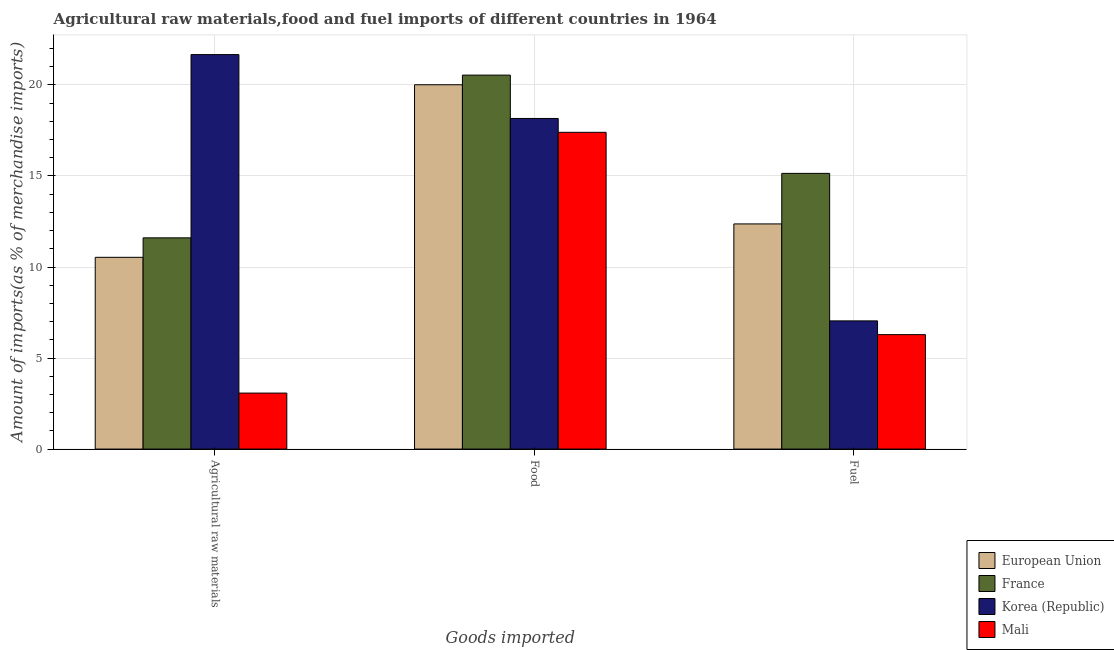How many groups of bars are there?
Offer a very short reply. 3. Are the number of bars per tick equal to the number of legend labels?
Ensure brevity in your answer.  Yes. Are the number of bars on each tick of the X-axis equal?
Your answer should be compact. Yes. How many bars are there on the 3rd tick from the right?
Give a very brief answer. 4. What is the label of the 3rd group of bars from the left?
Keep it short and to the point. Fuel. What is the percentage of raw materials imports in Korea (Republic)?
Keep it short and to the point. 21.67. Across all countries, what is the maximum percentage of food imports?
Offer a very short reply. 20.54. Across all countries, what is the minimum percentage of food imports?
Your answer should be compact. 17.4. In which country was the percentage of raw materials imports minimum?
Your answer should be very brief. Mali. What is the total percentage of food imports in the graph?
Provide a short and direct response. 76.11. What is the difference between the percentage of food imports in France and that in Mali?
Provide a succinct answer. 3.14. What is the difference between the percentage of raw materials imports in Korea (Republic) and the percentage of food imports in France?
Give a very brief answer. 1.13. What is the average percentage of food imports per country?
Make the answer very short. 19.03. What is the difference between the percentage of raw materials imports and percentage of fuel imports in France?
Make the answer very short. -3.54. In how many countries, is the percentage of food imports greater than 2 %?
Your answer should be very brief. 4. What is the ratio of the percentage of food imports in European Union to that in Mali?
Your answer should be very brief. 1.15. Is the difference between the percentage of food imports in Mali and European Union greater than the difference between the percentage of raw materials imports in Mali and European Union?
Offer a very short reply. Yes. What is the difference between the highest and the second highest percentage of food imports?
Keep it short and to the point. 0.53. What is the difference between the highest and the lowest percentage of fuel imports?
Give a very brief answer. 8.86. In how many countries, is the percentage of fuel imports greater than the average percentage of fuel imports taken over all countries?
Provide a succinct answer. 2. Is the sum of the percentage of food imports in Mali and Korea (Republic) greater than the maximum percentage of raw materials imports across all countries?
Give a very brief answer. Yes. What does the 1st bar from the right in Food represents?
Offer a terse response. Mali. Is it the case that in every country, the sum of the percentage of raw materials imports and percentage of food imports is greater than the percentage of fuel imports?
Keep it short and to the point. Yes. How many bars are there?
Offer a very short reply. 12. Are the values on the major ticks of Y-axis written in scientific E-notation?
Your answer should be very brief. No. Does the graph contain any zero values?
Offer a very short reply. No. Does the graph contain grids?
Provide a succinct answer. Yes. Where does the legend appear in the graph?
Ensure brevity in your answer.  Bottom right. How many legend labels are there?
Provide a short and direct response. 4. What is the title of the graph?
Keep it short and to the point. Agricultural raw materials,food and fuel imports of different countries in 1964. What is the label or title of the X-axis?
Your answer should be compact. Goods imported. What is the label or title of the Y-axis?
Make the answer very short. Amount of imports(as % of merchandise imports). What is the Amount of imports(as % of merchandise imports) of European Union in Agricultural raw materials?
Your answer should be very brief. 10.53. What is the Amount of imports(as % of merchandise imports) in France in Agricultural raw materials?
Make the answer very short. 11.6. What is the Amount of imports(as % of merchandise imports) in Korea (Republic) in Agricultural raw materials?
Your response must be concise. 21.67. What is the Amount of imports(as % of merchandise imports) in Mali in Agricultural raw materials?
Offer a very short reply. 3.08. What is the Amount of imports(as % of merchandise imports) of European Union in Food?
Your answer should be very brief. 20.01. What is the Amount of imports(as % of merchandise imports) in France in Food?
Give a very brief answer. 20.54. What is the Amount of imports(as % of merchandise imports) of Korea (Republic) in Food?
Keep it short and to the point. 18.16. What is the Amount of imports(as % of merchandise imports) in Mali in Food?
Provide a short and direct response. 17.4. What is the Amount of imports(as % of merchandise imports) of European Union in Fuel?
Offer a very short reply. 12.37. What is the Amount of imports(as % of merchandise imports) in France in Fuel?
Your response must be concise. 15.14. What is the Amount of imports(as % of merchandise imports) in Korea (Republic) in Fuel?
Provide a short and direct response. 7.04. What is the Amount of imports(as % of merchandise imports) in Mali in Fuel?
Keep it short and to the point. 6.29. Across all Goods imported, what is the maximum Amount of imports(as % of merchandise imports) of European Union?
Offer a very short reply. 20.01. Across all Goods imported, what is the maximum Amount of imports(as % of merchandise imports) in France?
Your answer should be very brief. 20.54. Across all Goods imported, what is the maximum Amount of imports(as % of merchandise imports) in Korea (Republic)?
Your answer should be very brief. 21.67. Across all Goods imported, what is the maximum Amount of imports(as % of merchandise imports) in Mali?
Your answer should be compact. 17.4. Across all Goods imported, what is the minimum Amount of imports(as % of merchandise imports) in European Union?
Keep it short and to the point. 10.53. Across all Goods imported, what is the minimum Amount of imports(as % of merchandise imports) of France?
Ensure brevity in your answer.  11.6. Across all Goods imported, what is the minimum Amount of imports(as % of merchandise imports) in Korea (Republic)?
Provide a short and direct response. 7.04. Across all Goods imported, what is the minimum Amount of imports(as % of merchandise imports) in Mali?
Make the answer very short. 3.08. What is the total Amount of imports(as % of merchandise imports) in European Union in the graph?
Make the answer very short. 42.91. What is the total Amount of imports(as % of merchandise imports) in France in the graph?
Ensure brevity in your answer.  47.29. What is the total Amount of imports(as % of merchandise imports) of Korea (Republic) in the graph?
Your answer should be very brief. 46.87. What is the total Amount of imports(as % of merchandise imports) in Mali in the graph?
Ensure brevity in your answer.  26.76. What is the difference between the Amount of imports(as % of merchandise imports) in European Union in Agricultural raw materials and that in Food?
Ensure brevity in your answer.  -9.48. What is the difference between the Amount of imports(as % of merchandise imports) of France in Agricultural raw materials and that in Food?
Your response must be concise. -8.94. What is the difference between the Amount of imports(as % of merchandise imports) in Korea (Republic) in Agricultural raw materials and that in Food?
Offer a terse response. 3.51. What is the difference between the Amount of imports(as % of merchandise imports) of Mali in Agricultural raw materials and that in Food?
Keep it short and to the point. -14.32. What is the difference between the Amount of imports(as % of merchandise imports) of European Union in Agricultural raw materials and that in Fuel?
Your answer should be compact. -1.84. What is the difference between the Amount of imports(as % of merchandise imports) of France in Agricultural raw materials and that in Fuel?
Make the answer very short. -3.54. What is the difference between the Amount of imports(as % of merchandise imports) of Korea (Republic) in Agricultural raw materials and that in Fuel?
Your response must be concise. 14.63. What is the difference between the Amount of imports(as % of merchandise imports) in Mali in Agricultural raw materials and that in Fuel?
Provide a succinct answer. -3.21. What is the difference between the Amount of imports(as % of merchandise imports) of European Union in Food and that in Fuel?
Offer a very short reply. 7.64. What is the difference between the Amount of imports(as % of merchandise imports) in France in Food and that in Fuel?
Keep it short and to the point. 5.4. What is the difference between the Amount of imports(as % of merchandise imports) of Korea (Republic) in Food and that in Fuel?
Make the answer very short. 11.12. What is the difference between the Amount of imports(as % of merchandise imports) of Mali in Food and that in Fuel?
Your answer should be compact. 11.11. What is the difference between the Amount of imports(as % of merchandise imports) of European Union in Agricultural raw materials and the Amount of imports(as % of merchandise imports) of France in Food?
Give a very brief answer. -10.01. What is the difference between the Amount of imports(as % of merchandise imports) in European Union in Agricultural raw materials and the Amount of imports(as % of merchandise imports) in Korea (Republic) in Food?
Offer a very short reply. -7.63. What is the difference between the Amount of imports(as % of merchandise imports) of European Union in Agricultural raw materials and the Amount of imports(as % of merchandise imports) of Mali in Food?
Provide a succinct answer. -6.87. What is the difference between the Amount of imports(as % of merchandise imports) of France in Agricultural raw materials and the Amount of imports(as % of merchandise imports) of Korea (Republic) in Food?
Your response must be concise. -6.56. What is the difference between the Amount of imports(as % of merchandise imports) in France in Agricultural raw materials and the Amount of imports(as % of merchandise imports) in Mali in Food?
Keep it short and to the point. -5.8. What is the difference between the Amount of imports(as % of merchandise imports) of Korea (Republic) in Agricultural raw materials and the Amount of imports(as % of merchandise imports) of Mali in Food?
Your response must be concise. 4.27. What is the difference between the Amount of imports(as % of merchandise imports) in European Union in Agricultural raw materials and the Amount of imports(as % of merchandise imports) in France in Fuel?
Provide a short and direct response. -4.61. What is the difference between the Amount of imports(as % of merchandise imports) of European Union in Agricultural raw materials and the Amount of imports(as % of merchandise imports) of Korea (Republic) in Fuel?
Your answer should be compact. 3.49. What is the difference between the Amount of imports(as % of merchandise imports) in European Union in Agricultural raw materials and the Amount of imports(as % of merchandise imports) in Mali in Fuel?
Provide a succinct answer. 4.25. What is the difference between the Amount of imports(as % of merchandise imports) of France in Agricultural raw materials and the Amount of imports(as % of merchandise imports) of Korea (Republic) in Fuel?
Your answer should be compact. 4.56. What is the difference between the Amount of imports(as % of merchandise imports) of France in Agricultural raw materials and the Amount of imports(as % of merchandise imports) of Mali in Fuel?
Ensure brevity in your answer.  5.32. What is the difference between the Amount of imports(as % of merchandise imports) in Korea (Republic) in Agricultural raw materials and the Amount of imports(as % of merchandise imports) in Mali in Fuel?
Your response must be concise. 15.38. What is the difference between the Amount of imports(as % of merchandise imports) in European Union in Food and the Amount of imports(as % of merchandise imports) in France in Fuel?
Your response must be concise. 4.87. What is the difference between the Amount of imports(as % of merchandise imports) in European Union in Food and the Amount of imports(as % of merchandise imports) in Korea (Republic) in Fuel?
Keep it short and to the point. 12.97. What is the difference between the Amount of imports(as % of merchandise imports) of European Union in Food and the Amount of imports(as % of merchandise imports) of Mali in Fuel?
Ensure brevity in your answer.  13.73. What is the difference between the Amount of imports(as % of merchandise imports) of France in Food and the Amount of imports(as % of merchandise imports) of Korea (Republic) in Fuel?
Offer a terse response. 13.5. What is the difference between the Amount of imports(as % of merchandise imports) in France in Food and the Amount of imports(as % of merchandise imports) in Mali in Fuel?
Your response must be concise. 14.26. What is the difference between the Amount of imports(as % of merchandise imports) in Korea (Republic) in Food and the Amount of imports(as % of merchandise imports) in Mali in Fuel?
Offer a very short reply. 11.87. What is the average Amount of imports(as % of merchandise imports) in European Union per Goods imported?
Your answer should be very brief. 14.3. What is the average Amount of imports(as % of merchandise imports) in France per Goods imported?
Provide a short and direct response. 15.76. What is the average Amount of imports(as % of merchandise imports) of Korea (Republic) per Goods imported?
Give a very brief answer. 15.62. What is the average Amount of imports(as % of merchandise imports) of Mali per Goods imported?
Keep it short and to the point. 8.92. What is the difference between the Amount of imports(as % of merchandise imports) of European Union and Amount of imports(as % of merchandise imports) of France in Agricultural raw materials?
Provide a succinct answer. -1.07. What is the difference between the Amount of imports(as % of merchandise imports) of European Union and Amount of imports(as % of merchandise imports) of Korea (Republic) in Agricultural raw materials?
Give a very brief answer. -11.14. What is the difference between the Amount of imports(as % of merchandise imports) of European Union and Amount of imports(as % of merchandise imports) of Mali in Agricultural raw materials?
Your answer should be very brief. 7.46. What is the difference between the Amount of imports(as % of merchandise imports) of France and Amount of imports(as % of merchandise imports) of Korea (Republic) in Agricultural raw materials?
Make the answer very short. -10.07. What is the difference between the Amount of imports(as % of merchandise imports) of France and Amount of imports(as % of merchandise imports) of Mali in Agricultural raw materials?
Your response must be concise. 8.53. What is the difference between the Amount of imports(as % of merchandise imports) of Korea (Republic) and Amount of imports(as % of merchandise imports) of Mali in Agricultural raw materials?
Your answer should be very brief. 18.59. What is the difference between the Amount of imports(as % of merchandise imports) in European Union and Amount of imports(as % of merchandise imports) in France in Food?
Your answer should be very brief. -0.53. What is the difference between the Amount of imports(as % of merchandise imports) in European Union and Amount of imports(as % of merchandise imports) in Korea (Republic) in Food?
Offer a very short reply. 1.85. What is the difference between the Amount of imports(as % of merchandise imports) of European Union and Amount of imports(as % of merchandise imports) of Mali in Food?
Give a very brief answer. 2.61. What is the difference between the Amount of imports(as % of merchandise imports) of France and Amount of imports(as % of merchandise imports) of Korea (Republic) in Food?
Make the answer very short. 2.38. What is the difference between the Amount of imports(as % of merchandise imports) in France and Amount of imports(as % of merchandise imports) in Mali in Food?
Give a very brief answer. 3.14. What is the difference between the Amount of imports(as % of merchandise imports) of Korea (Republic) and Amount of imports(as % of merchandise imports) of Mali in Food?
Offer a terse response. 0.76. What is the difference between the Amount of imports(as % of merchandise imports) in European Union and Amount of imports(as % of merchandise imports) in France in Fuel?
Offer a terse response. -2.78. What is the difference between the Amount of imports(as % of merchandise imports) of European Union and Amount of imports(as % of merchandise imports) of Korea (Republic) in Fuel?
Your answer should be very brief. 5.33. What is the difference between the Amount of imports(as % of merchandise imports) in European Union and Amount of imports(as % of merchandise imports) in Mali in Fuel?
Keep it short and to the point. 6.08. What is the difference between the Amount of imports(as % of merchandise imports) in France and Amount of imports(as % of merchandise imports) in Korea (Republic) in Fuel?
Offer a terse response. 8.1. What is the difference between the Amount of imports(as % of merchandise imports) in France and Amount of imports(as % of merchandise imports) in Mali in Fuel?
Ensure brevity in your answer.  8.86. What is the difference between the Amount of imports(as % of merchandise imports) of Korea (Republic) and Amount of imports(as % of merchandise imports) of Mali in Fuel?
Offer a very short reply. 0.76. What is the ratio of the Amount of imports(as % of merchandise imports) of European Union in Agricultural raw materials to that in Food?
Offer a very short reply. 0.53. What is the ratio of the Amount of imports(as % of merchandise imports) in France in Agricultural raw materials to that in Food?
Your answer should be compact. 0.56. What is the ratio of the Amount of imports(as % of merchandise imports) in Korea (Republic) in Agricultural raw materials to that in Food?
Provide a short and direct response. 1.19. What is the ratio of the Amount of imports(as % of merchandise imports) of Mali in Agricultural raw materials to that in Food?
Ensure brevity in your answer.  0.18. What is the ratio of the Amount of imports(as % of merchandise imports) in European Union in Agricultural raw materials to that in Fuel?
Provide a short and direct response. 0.85. What is the ratio of the Amount of imports(as % of merchandise imports) in France in Agricultural raw materials to that in Fuel?
Your answer should be very brief. 0.77. What is the ratio of the Amount of imports(as % of merchandise imports) in Korea (Republic) in Agricultural raw materials to that in Fuel?
Your answer should be very brief. 3.08. What is the ratio of the Amount of imports(as % of merchandise imports) in Mali in Agricultural raw materials to that in Fuel?
Make the answer very short. 0.49. What is the ratio of the Amount of imports(as % of merchandise imports) in European Union in Food to that in Fuel?
Your answer should be very brief. 1.62. What is the ratio of the Amount of imports(as % of merchandise imports) in France in Food to that in Fuel?
Provide a short and direct response. 1.36. What is the ratio of the Amount of imports(as % of merchandise imports) of Korea (Republic) in Food to that in Fuel?
Provide a succinct answer. 2.58. What is the ratio of the Amount of imports(as % of merchandise imports) of Mali in Food to that in Fuel?
Offer a very short reply. 2.77. What is the difference between the highest and the second highest Amount of imports(as % of merchandise imports) in European Union?
Give a very brief answer. 7.64. What is the difference between the highest and the second highest Amount of imports(as % of merchandise imports) in France?
Give a very brief answer. 5.4. What is the difference between the highest and the second highest Amount of imports(as % of merchandise imports) of Korea (Republic)?
Keep it short and to the point. 3.51. What is the difference between the highest and the second highest Amount of imports(as % of merchandise imports) of Mali?
Provide a short and direct response. 11.11. What is the difference between the highest and the lowest Amount of imports(as % of merchandise imports) in European Union?
Give a very brief answer. 9.48. What is the difference between the highest and the lowest Amount of imports(as % of merchandise imports) of France?
Your answer should be compact. 8.94. What is the difference between the highest and the lowest Amount of imports(as % of merchandise imports) of Korea (Republic)?
Your answer should be very brief. 14.63. What is the difference between the highest and the lowest Amount of imports(as % of merchandise imports) of Mali?
Your answer should be compact. 14.32. 